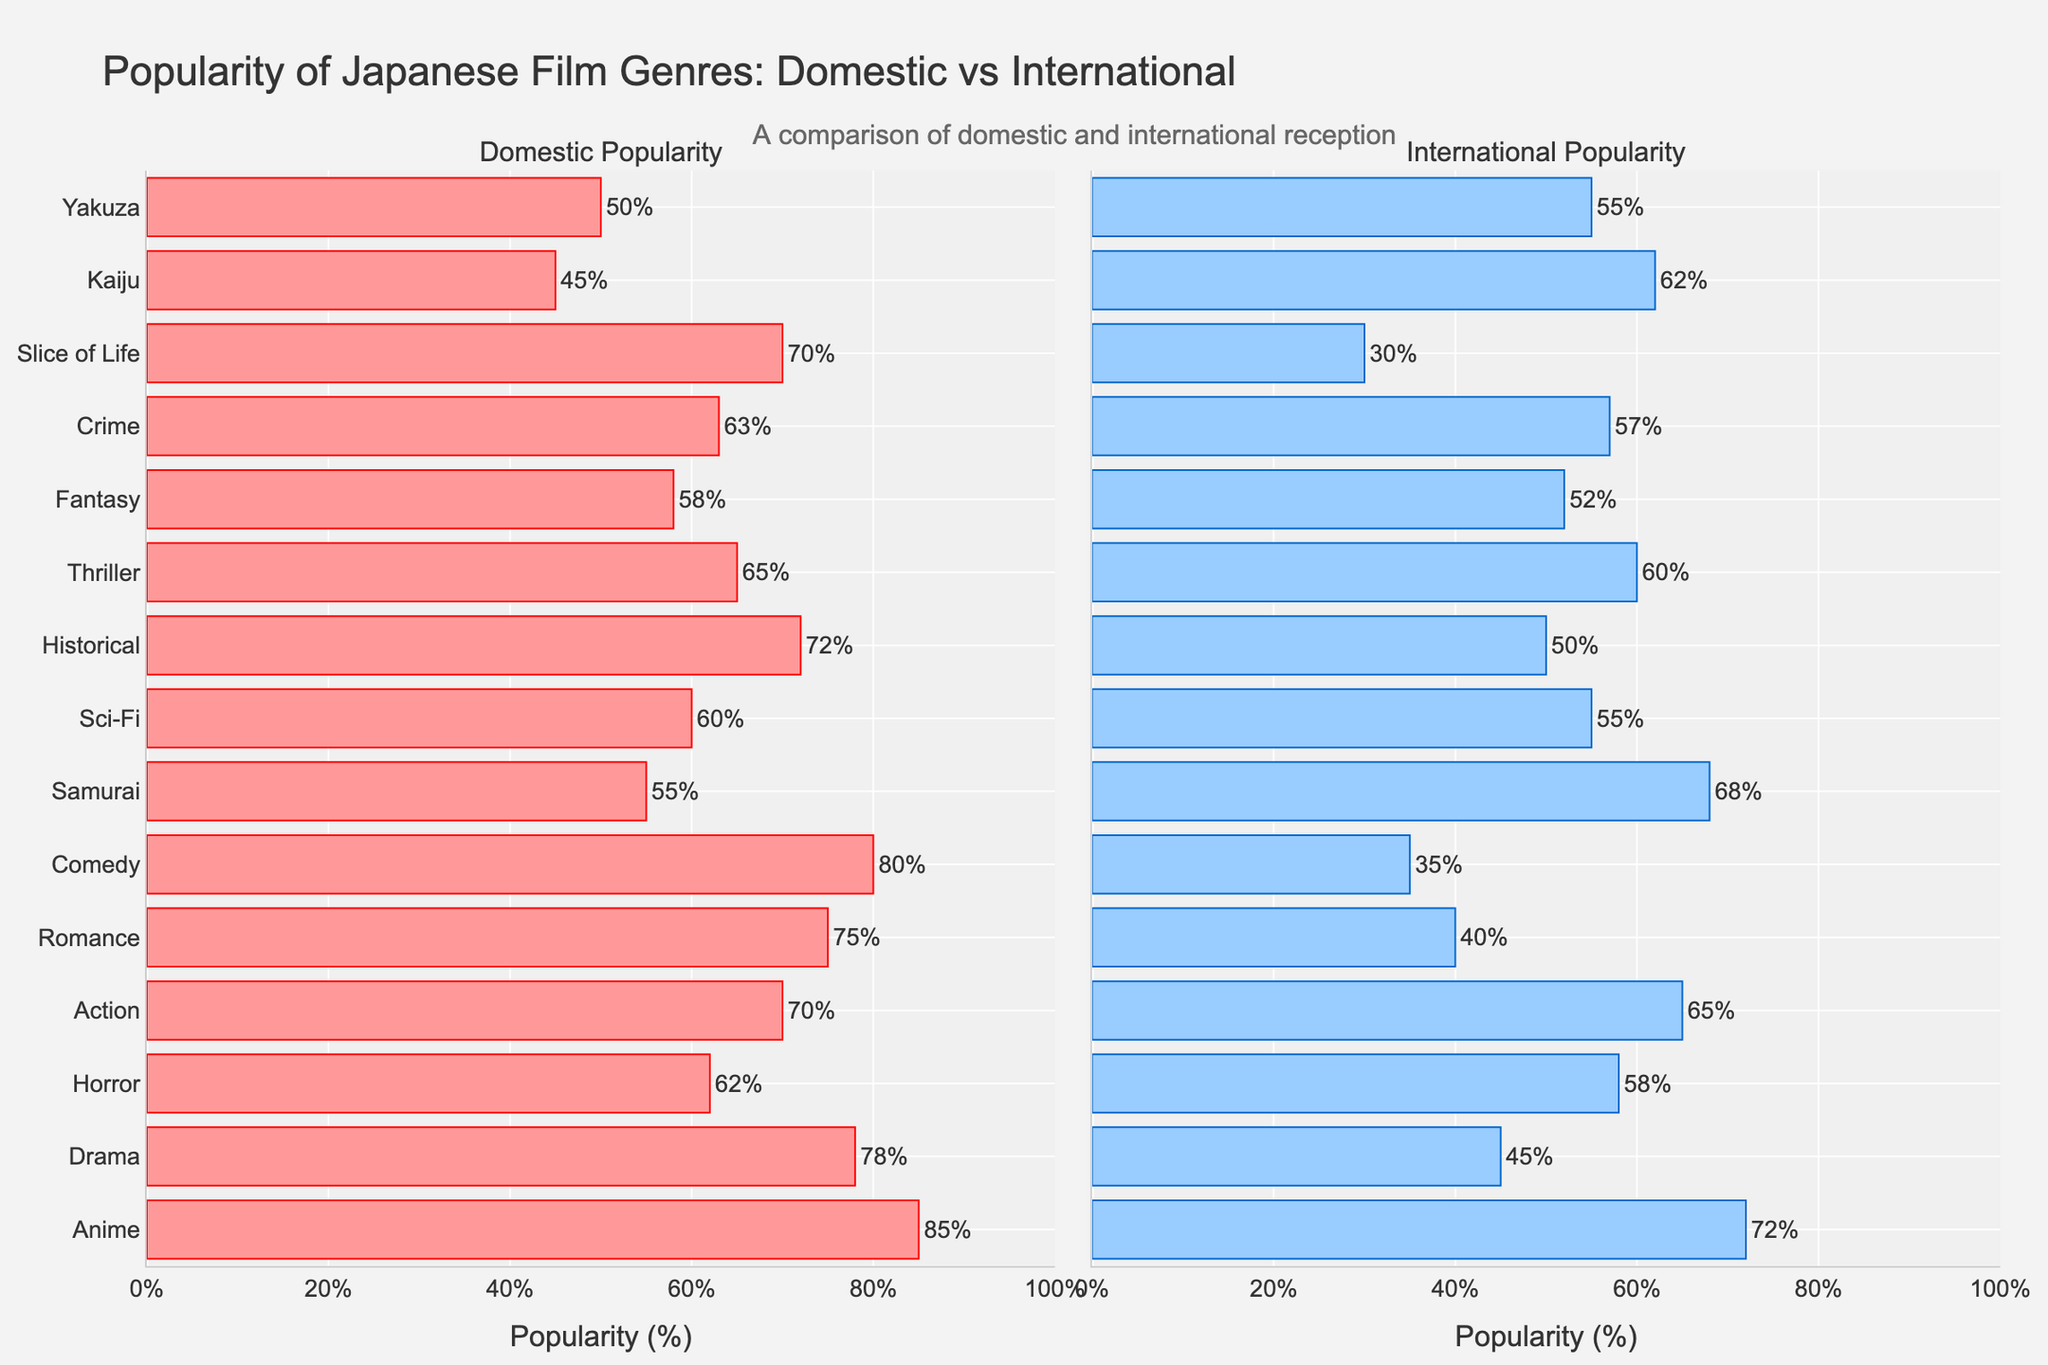Which genre has the highest domestic popularity? Look at the bar chart for domestic popularity and identify the genre with the longest bar. In this case, the genre with the highest percentage is "Anime" with 85%.
Answer: Anime Which genre has the greatest difference in popularity between domestic and international markets? Calculate the absolute differences between domestic and international popularity for each genre and find the maximum value. The differences are: Anime (13), Drama (33), Horror (4), Action (5), Romance (35), Comedy (45), Samurai (13), Sci-Fi (5), Historical (22), Thriller (5), Fantasy (6), Crime (6), Slice of Life (40), Kaiju (17), Yakuza (5). The greatest difference is for "Comedy" with 45%.
Answer: Comedy Which genre is more popular internationally than domestically? Compare bars on both sides and identify the genres where the international bar is longer than the domestic bar. "Samurai" (68% international vs. 55% domestic) and "Kaiju" (62% international vs. 45% domestic) fit this criterion.
Answer: Samurai, Kaiju For which genre is the domestic popularity exactly equal to its international popularity? Check for bars with equal lengths on both sides. None of the genres have exactly equal domestic and international popularity based on the chart.
Answer: None What is the average popularity of Horror across both domestic and international markets? Add the domestic popularity (62%) and international popularity (58%) of Horror and divide by two: (62 + 58) / 2 = 60.
Answer: 60 Which genre has the lowest international popularity? Identify the genre with the shortest bar on the international side. "Slice of Life" has the lowest international popularity at 30%.
Answer: Slice of Life How much more popular is Anime domestically than internationally? Subtract the international popularity percentage of Anime (72%) from its domestic popularity percentage (85%): 85 - 72 = 13.
Answer: 13 Which genres have domestic popularity between 70% and 80%? Identify the genres whose domestic popularity bars fall within this range. The genres are Drama (78%), Action (70%), Romance (75%), Comedy (80%), and Slice of Life (70%).
Answer: Drama, Action, Romance, Comedy, Slice of Life Which genre has nearly equal popularity in both markets, with a difference of 5% or less? Find genres where the difference between domestic and international popularity is 5% or less. These genres are Horror (62% - 58% = 4%), Action (70% - 65% = 5%), Thriller (65% - 60% = 5%), Crime (63% - 57% = 6% which is slightly over 5%), Sci-Fi (60% - 55% = 5%), and Yakuza (50% - 55% = 5%).
Answer: Horror, Action, Thriller, Sci-Fi, Yakuza 